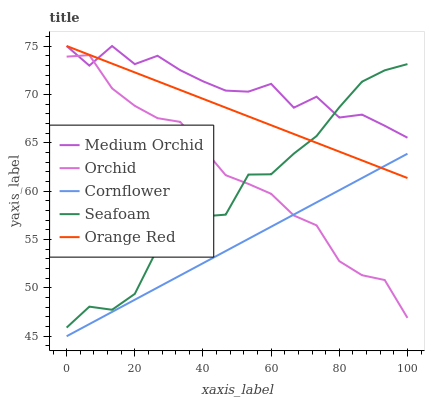Does Seafoam have the minimum area under the curve?
Answer yes or no. No. Does Seafoam have the maximum area under the curve?
Answer yes or no. No. Is Medium Orchid the smoothest?
Answer yes or no. No. Is Medium Orchid the roughest?
Answer yes or no. No. Does Seafoam have the lowest value?
Answer yes or no. No. Does Seafoam have the highest value?
Answer yes or no. No. Is Cornflower less than Seafoam?
Answer yes or no. Yes. Is Seafoam greater than Cornflower?
Answer yes or no. Yes. Does Cornflower intersect Seafoam?
Answer yes or no. No. 